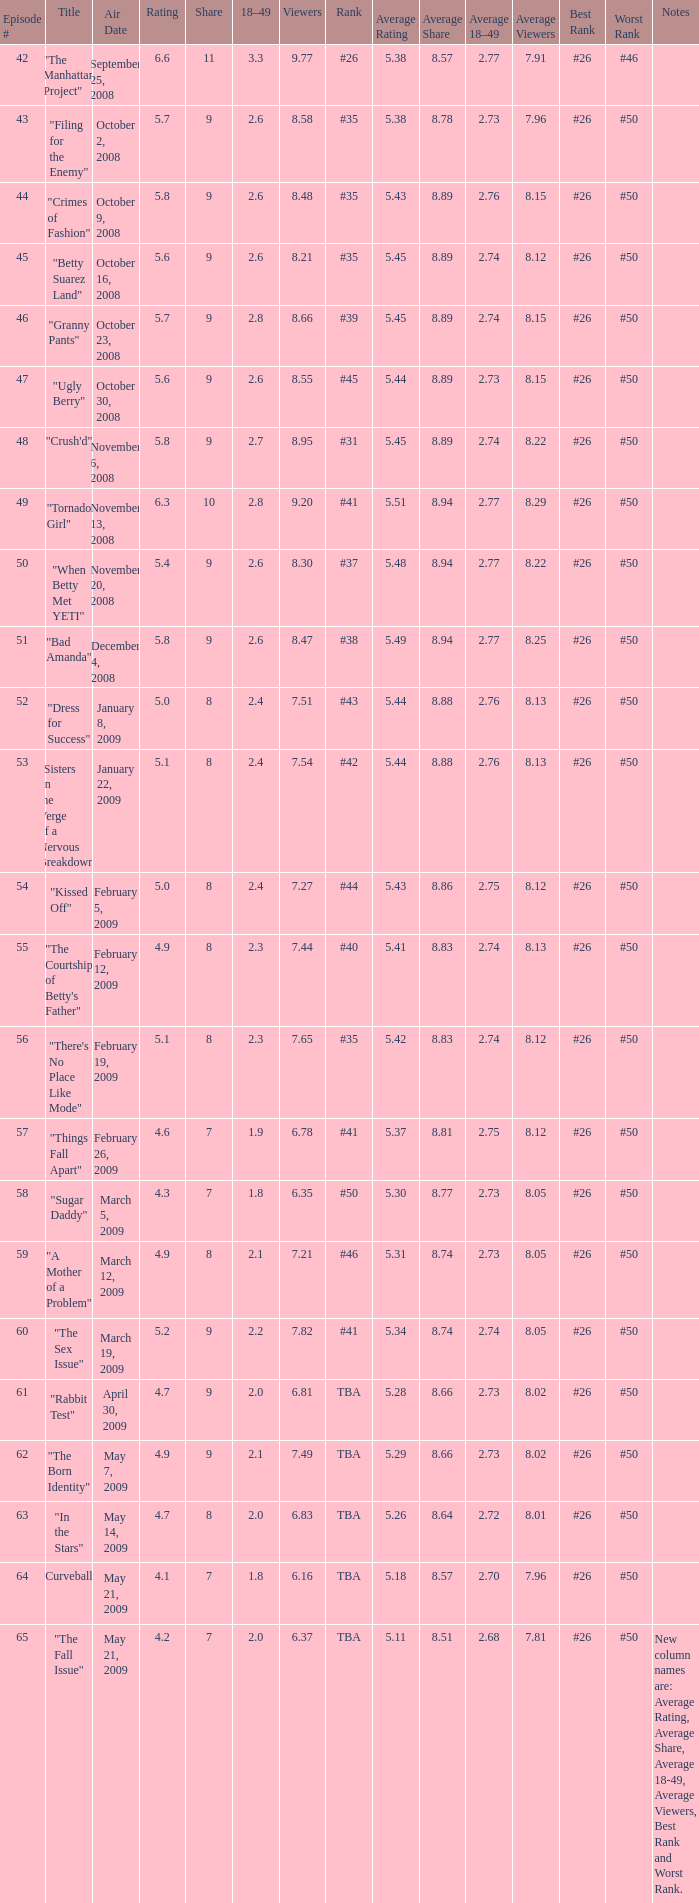What is the lowest Viewers that has an Episode #higher than 58 with a title of "curveball" less than 4.1 rating? None. 